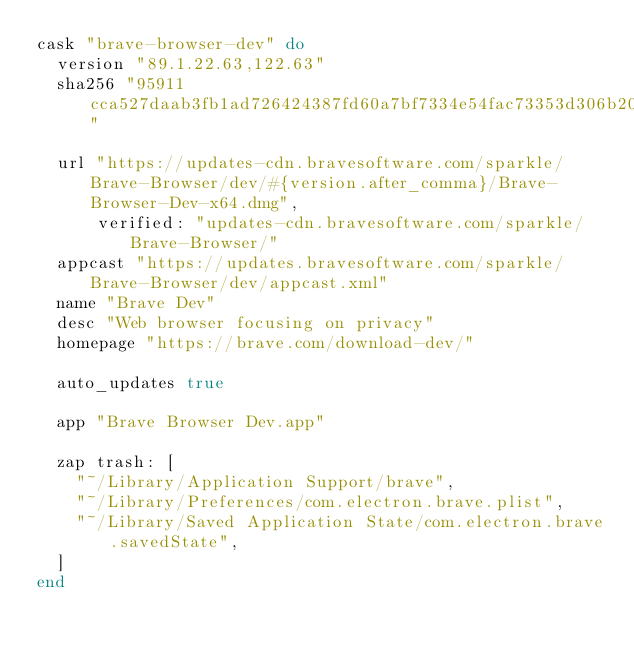Convert code to text. <code><loc_0><loc_0><loc_500><loc_500><_Ruby_>cask "brave-browser-dev" do
  version "89.1.22.63,122.63"
  sha256 "95911cca527daab3fb1ad726424387fd60a7bf7334e54fac73353d306b202ec7"

  url "https://updates-cdn.bravesoftware.com/sparkle/Brave-Browser/dev/#{version.after_comma}/Brave-Browser-Dev-x64.dmg",
      verified: "updates-cdn.bravesoftware.com/sparkle/Brave-Browser/"
  appcast "https://updates.bravesoftware.com/sparkle/Brave-Browser/dev/appcast.xml"
  name "Brave Dev"
  desc "Web browser focusing on privacy"
  homepage "https://brave.com/download-dev/"

  auto_updates true

  app "Brave Browser Dev.app"

  zap trash: [
    "~/Library/Application Support/brave",
    "~/Library/Preferences/com.electron.brave.plist",
    "~/Library/Saved Application State/com.electron.brave.savedState",
  ]
end
</code> 